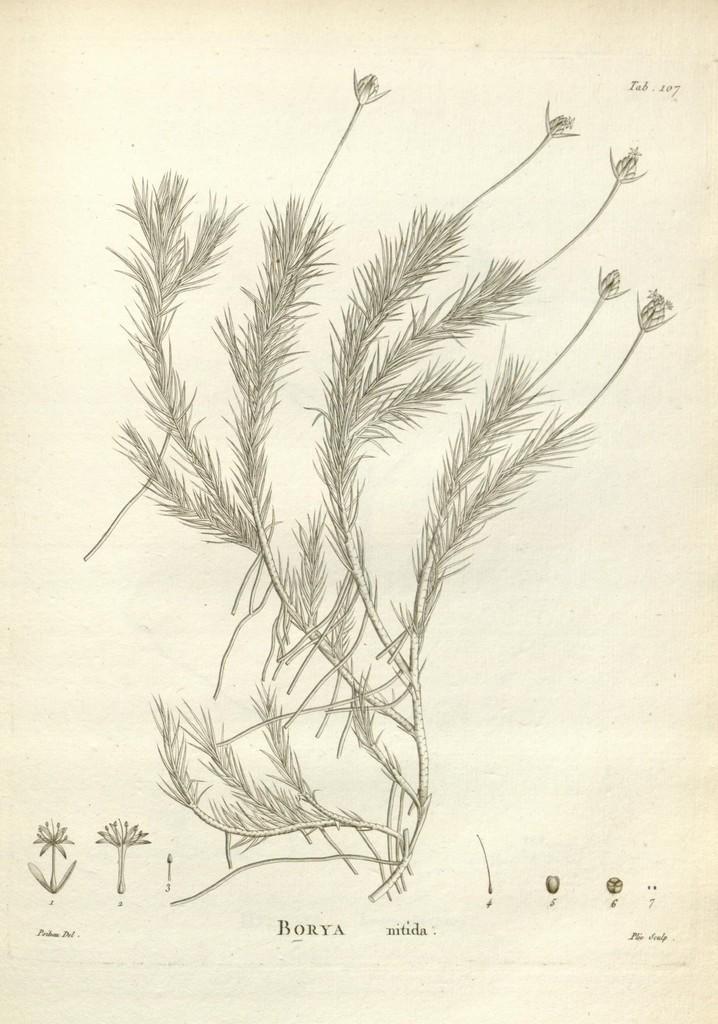Can you describe this image briefly? In this picture I can observe sketch of a plant in the paper. On the bottom of the picture I can observe some text. The background is in cream color. 